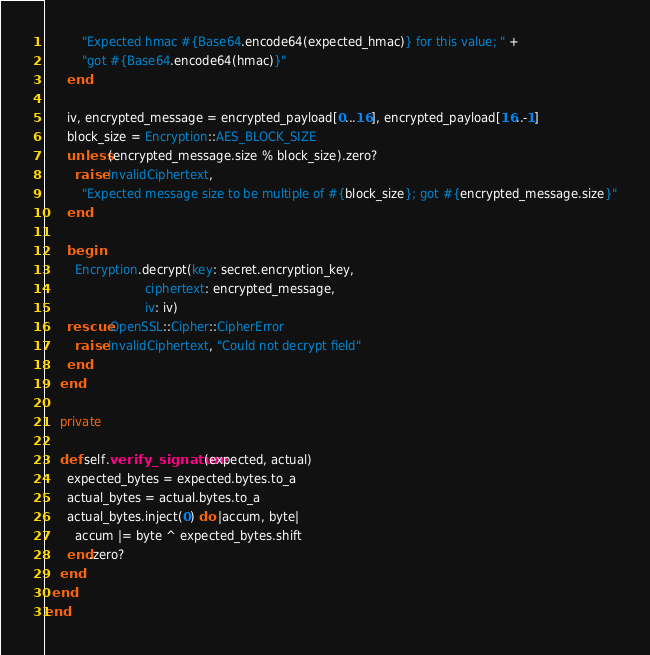<code> <loc_0><loc_0><loc_500><loc_500><_Ruby_>          "Expected hmac #{Base64.encode64(expected_hmac)} for this value; " +
          "got #{Base64.encode64(hmac)}"
      end

      iv, encrypted_message = encrypted_payload[0...16], encrypted_payload[16..-1]
      block_size = Encryption::AES_BLOCK_SIZE
      unless (encrypted_message.size % block_size).zero?
        raise InvalidCiphertext,
          "Expected message size to be multiple of #{block_size}; got #{encrypted_message.size}"
      end

      begin
        Encryption.decrypt(key: secret.encryption_key,
                           ciphertext: encrypted_message,
                           iv: iv)
      rescue OpenSSL::Cipher::CipherError
        raise InvalidCiphertext, "Could not decrypt field"
      end
    end

    private

    def self.verify_signature(expected, actual)
      expected_bytes = expected.bytes.to_a
      actual_bytes = actual.bytes.to_a
      actual_bytes.inject(0) do |accum, byte|
        accum |= byte ^ expected_bytes.shift
      end.zero?
    end
  end
end
</code> 